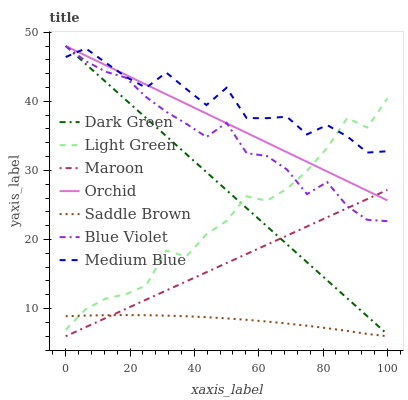Does Saddle Brown have the minimum area under the curve?
Answer yes or no. Yes. Does Medium Blue have the maximum area under the curve?
Answer yes or no. Yes. Does Maroon have the minimum area under the curve?
Answer yes or no. No. Does Maroon have the maximum area under the curve?
Answer yes or no. No. Is Maroon the smoothest?
Answer yes or no. Yes. Is Medium Blue the roughest?
Answer yes or no. Yes. Is Light Green the smoothest?
Answer yes or no. No. Is Light Green the roughest?
Answer yes or no. No. Does Maroon have the lowest value?
Answer yes or no. Yes. Does Light Green have the lowest value?
Answer yes or no. No. Does Orchid have the highest value?
Answer yes or no. Yes. Does Maroon have the highest value?
Answer yes or no. No. Is Saddle Brown less than Orchid?
Answer yes or no. Yes. Is Orchid greater than Saddle Brown?
Answer yes or no. Yes. Does Light Green intersect Saddle Brown?
Answer yes or no. Yes. Is Light Green less than Saddle Brown?
Answer yes or no. No. Is Light Green greater than Saddle Brown?
Answer yes or no. No. Does Saddle Brown intersect Orchid?
Answer yes or no. No. 